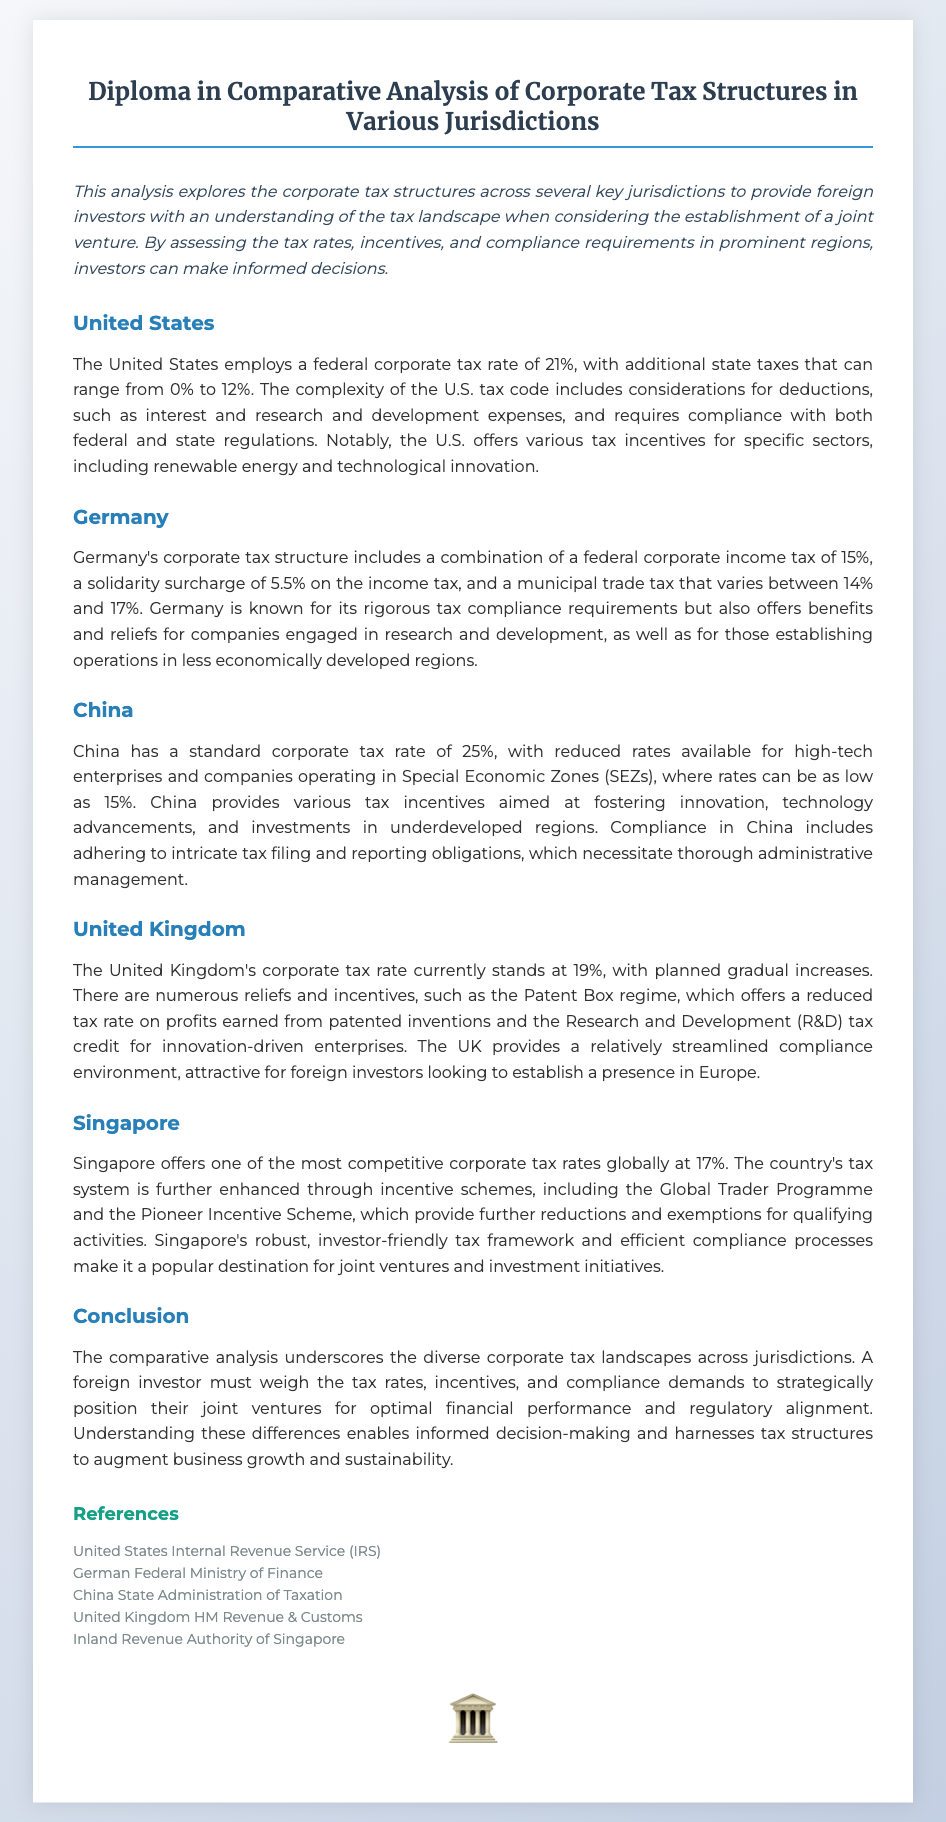What is the federal corporate tax rate in the United States? The federal corporate tax rate in the United States is 21%.
Answer: 21% What is Germany's corporate income tax rate? Germany's corporate income tax rate is 15%.
Answer: 15% What is the standard corporate tax rate in China? The standard corporate tax rate in China is 25%.
Answer: 25% What tax incentive does the United Kingdom offer for patented inventions? The United Kingdom offers the Patent Box regime for patented inventions.
Answer: Patent Box What is Singapore's corporate tax rate? Singapore's corporate tax rate is 17%.
Answer: 17% Which country offers reduced rates for companies in Special Economic Zones? China offers reduced rates for companies in Special Economic Zones.
Answer: China What is the compliance obligation in China described in the document? Compliance in China includes adhering to intricate tax filing and reporting obligations.
Answer: Intricate tax filing What aspect of tax structure is emphasized for foreign investors in the conclusion? The conclusion emphasizes weighing tax rates, incentives, and compliance demands.
Answer: Weighing tax rates Which reference is listed for the United Kingdom's tax authority? The reference listed for the United Kingdom's tax authority is HM Revenue & Customs.
Answer: HM Revenue & Customs 